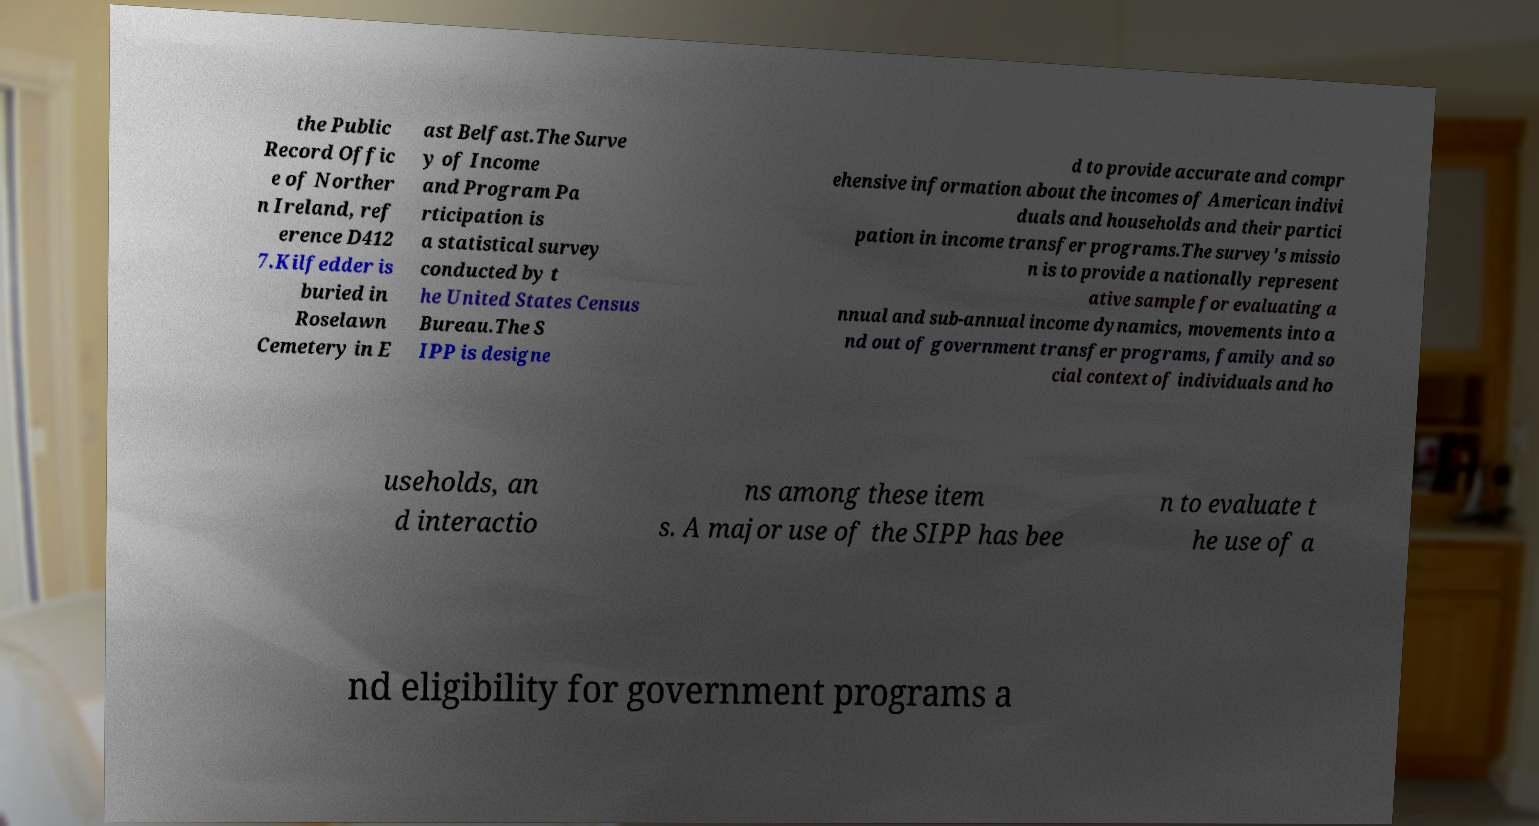Could you assist in decoding the text presented in this image and type it out clearly? the Public Record Offic e of Norther n Ireland, ref erence D412 7.Kilfedder is buried in Roselawn Cemetery in E ast Belfast.The Surve y of Income and Program Pa rticipation is a statistical survey conducted by t he United States Census Bureau.The S IPP is designe d to provide accurate and compr ehensive information about the incomes of American indivi duals and households and their partici pation in income transfer programs.The survey's missio n is to provide a nationally represent ative sample for evaluating a nnual and sub-annual income dynamics, movements into a nd out of government transfer programs, family and so cial context of individuals and ho useholds, an d interactio ns among these item s. A major use of the SIPP has bee n to evaluate t he use of a nd eligibility for government programs a 